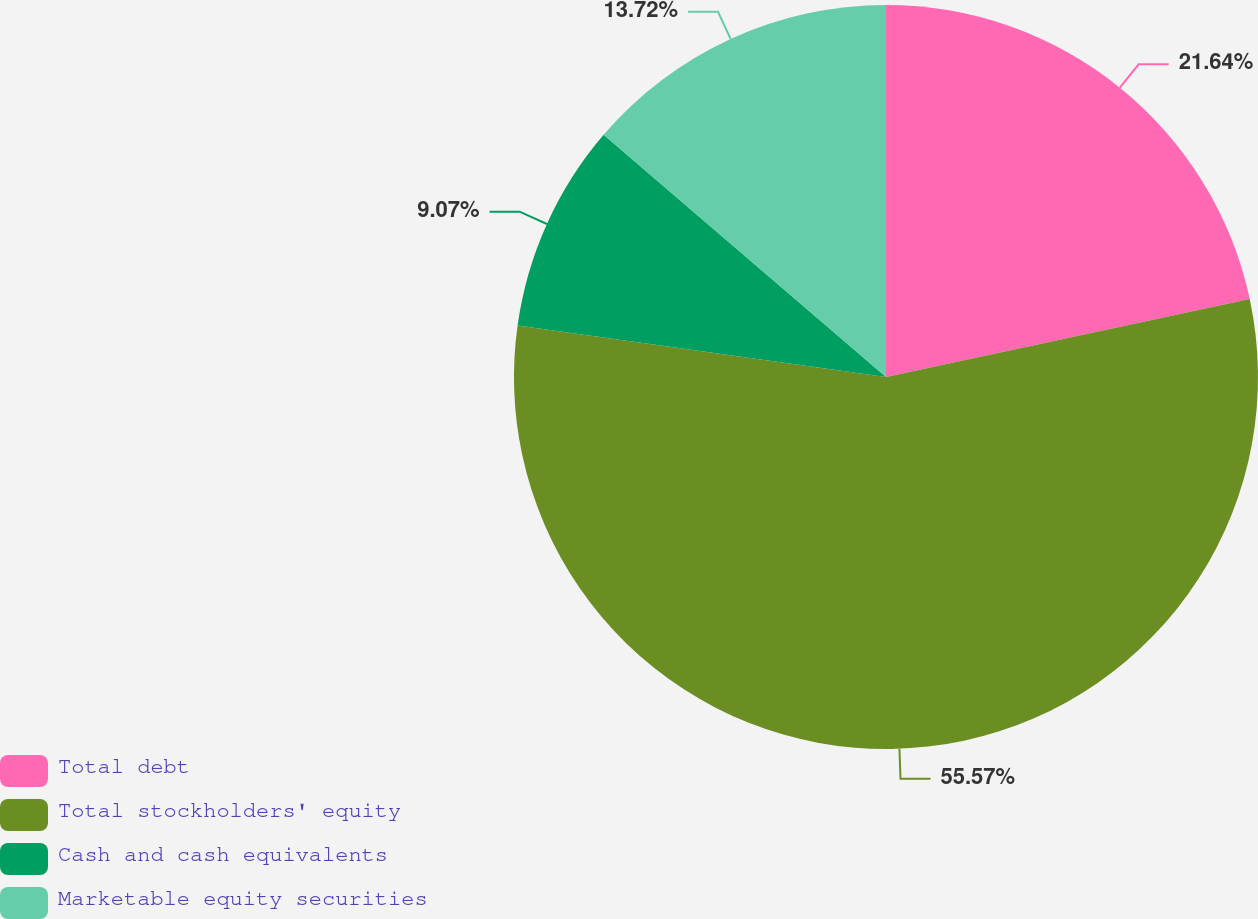Convert chart to OTSL. <chart><loc_0><loc_0><loc_500><loc_500><pie_chart><fcel>Total debt<fcel>Total stockholders' equity<fcel>Cash and cash equivalents<fcel>Marketable equity securities<nl><fcel>21.64%<fcel>55.58%<fcel>9.07%<fcel>13.72%<nl></chart> 